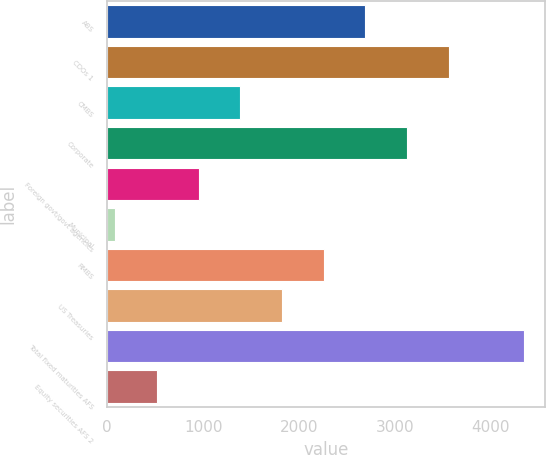Convert chart to OTSL. <chart><loc_0><loc_0><loc_500><loc_500><bar_chart><fcel>ABS<fcel>CDOs 1<fcel>CMBS<fcel>Corporate<fcel>Foreign govt/govt agencies<fcel>Municipal<fcel>RMBS<fcel>US Treasuries<fcel>Total fixed maturities AFS<fcel>Equity securities AFS 2<nl><fcel>2690.2<fcel>3559.6<fcel>1386.1<fcel>3124.9<fcel>951.4<fcel>82<fcel>2255.5<fcel>1820.8<fcel>4342<fcel>516.7<nl></chart> 